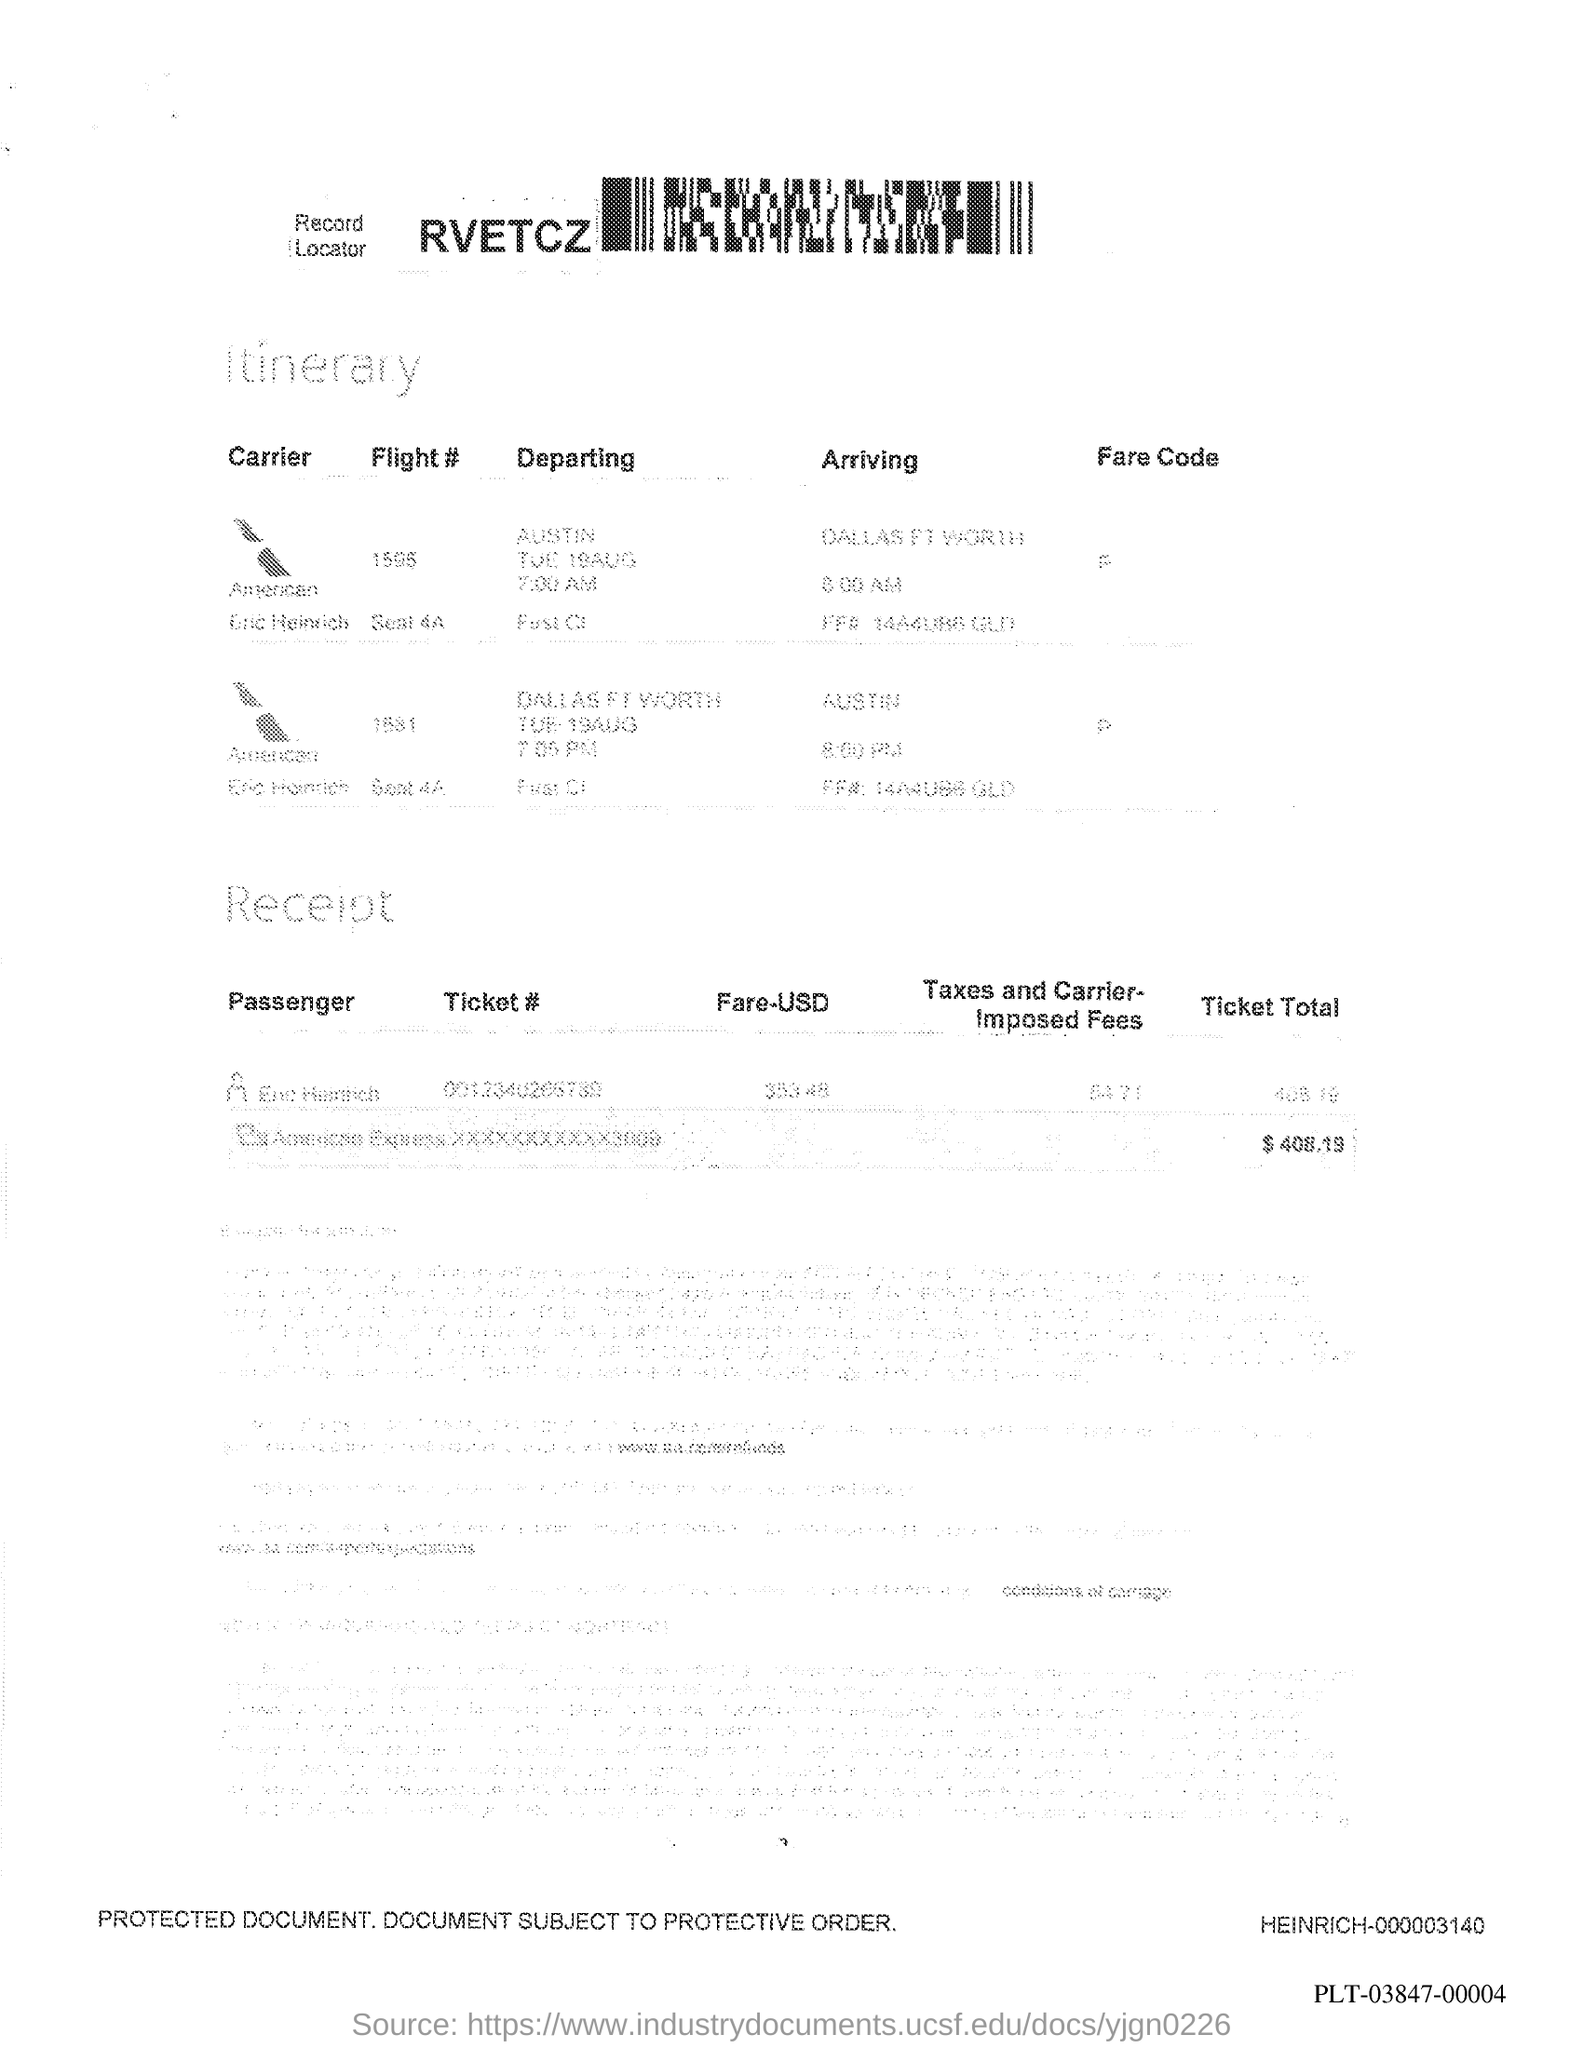What is the ticket total?
Keep it short and to the point. $ 408.19. What is the document about?
Offer a very short reply. Itinerary. What is the code written next to Record Locator?
Provide a short and direct response. RVETCZ. From where is the flight # 1595 departing?
Provide a succinct answer. Austin. 